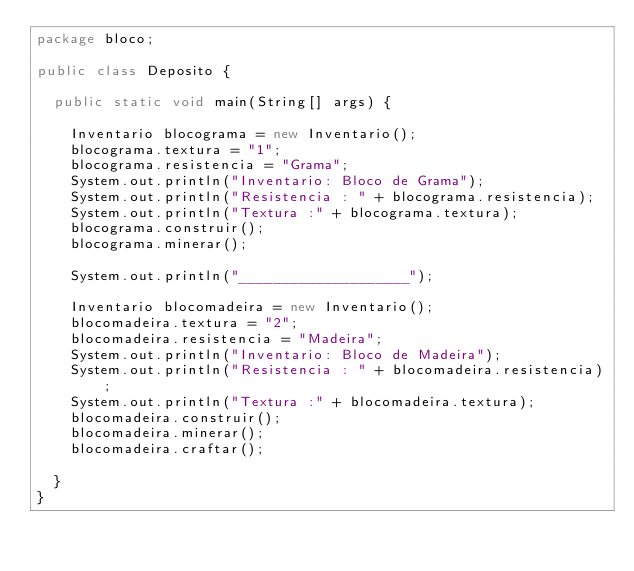<code> <loc_0><loc_0><loc_500><loc_500><_Java_>package bloco;

public class Deposito {

	public static void main(String[] args) {

		Inventario blocograma = new Inventario();
		blocograma.textura = "1";
		blocograma.resistencia = "Grama";
		System.out.println("Inventario: Bloco de Grama");
		System.out.println("Resistencia : " + blocograma.resistencia);
		System.out.println("Textura :" + blocograma.textura);
		blocograma.construir();
		blocograma.minerar();

		System.out.println("____________________");

		Inventario blocomadeira = new Inventario();
		blocomadeira.textura = "2";
		blocomadeira.resistencia = "Madeira";
		System.out.println("Inventario: Bloco de Madeira");
		System.out.println("Resistencia : " + blocomadeira.resistencia);
		System.out.println("Textura :" + blocomadeira.textura);
		blocomadeira.construir();
		blocomadeira.minerar();
		blocomadeira.craftar();

	}
}
</code> 